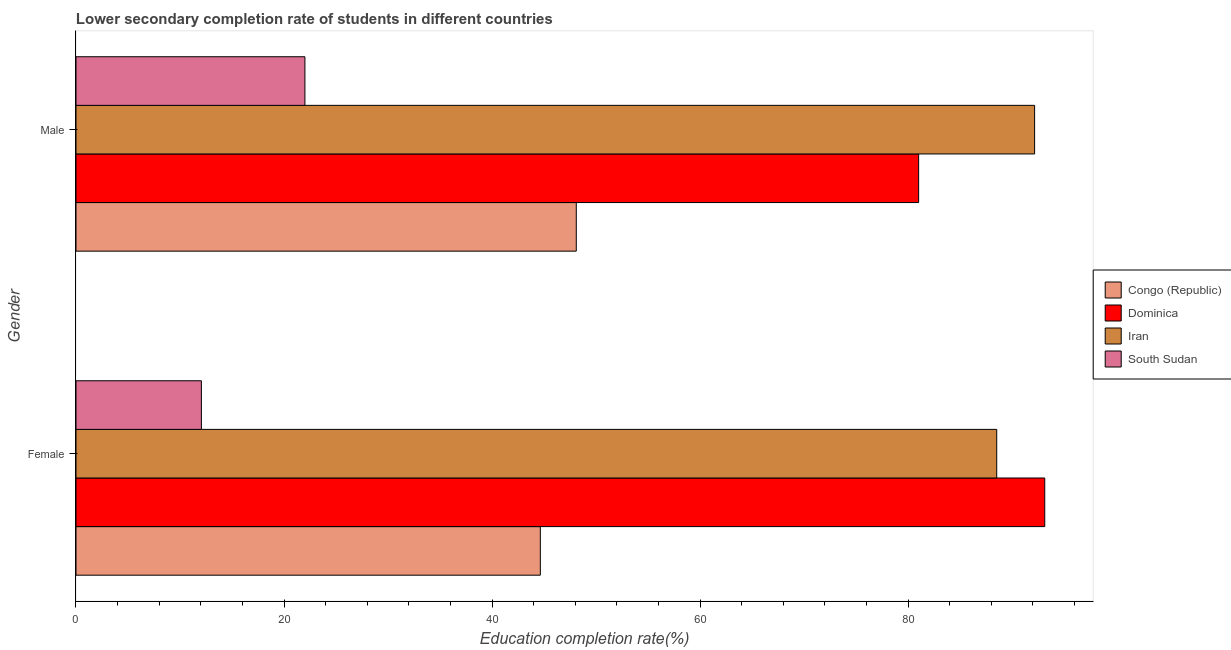How many groups of bars are there?
Make the answer very short. 2. Are the number of bars on each tick of the Y-axis equal?
Your answer should be compact. Yes. What is the label of the 2nd group of bars from the top?
Your response must be concise. Female. What is the education completion rate of male students in Dominica?
Ensure brevity in your answer.  81.01. Across all countries, what is the maximum education completion rate of male students?
Offer a very short reply. 92.16. Across all countries, what is the minimum education completion rate of female students?
Your response must be concise. 12.06. In which country was the education completion rate of male students maximum?
Offer a terse response. Iran. In which country was the education completion rate of female students minimum?
Your answer should be very brief. South Sudan. What is the total education completion rate of female students in the graph?
Offer a very short reply. 238.36. What is the difference between the education completion rate of female students in Iran and that in South Sudan?
Provide a succinct answer. 76.47. What is the difference between the education completion rate of male students in Dominica and the education completion rate of female students in Congo (Republic)?
Keep it short and to the point. 36.37. What is the average education completion rate of male students per country?
Ensure brevity in your answer.  60.82. What is the difference between the education completion rate of female students and education completion rate of male students in Iran?
Provide a short and direct response. -3.64. In how many countries, is the education completion rate of male students greater than 20 %?
Offer a terse response. 4. What is the ratio of the education completion rate of male students in Iran to that in Dominica?
Make the answer very short. 1.14. What does the 4th bar from the top in Male represents?
Make the answer very short. Congo (Republic). What does the 4th bar from the bottom in Male represents?
Give a very brief answer. South Sudan. How many bars are there?
Offer a very short reply. 8. Are the values on the major ticks of X-axis written in scientific E-notation?
Offer a terse response. No. Where does the legend appear in the graph?
Offer a very short reply. Center right. What is the title of the graph?
Provide a succinct answer. Lower secondary completion rate of students in different countries. Does "South Sudan" appear as one of the legend labels in the graph?
Offer a terse response. Yes. What is the label or title of the X-axis?
Make the answer very short. Education completion rate(%). What is the Education completion rate(%) in Congo (Republic) in Female?
Your answer should be compact. 44.64. What is the Education completion rate(%) in Dominica in Female?
Offer a very short reply. 93.14. What is the Education completion rate(%) of Iran in Female?
Ensure brevity in your answer.  88.52. What is the Education completion rate(%) in South Sudan in Female?
Provide a short and direct response. 12.06. What is the Education completion rate(%) of Congo (Republic) in Male?
Provide a short and direct response. 48.1. What is the Education completion rate(%) of Dominica in Male?
Provide a short and direct response. 81.01. What is the Education completion rate(%) of Iran in Male?
Your answer should be compact. 92.16. What is the Education completion rate(%) of South Sudan in Male?
Provide a short and direct response. 22.01. Across all Gender, what is the maximum Education completion rate(%) in Congo (Republic)?
Your response must be concise. 48.1. Across all Gender, what is the maximum Education completion rate(%) of Dominica?
Keep it short and to the point. 93.14. Across all Gender, what is the maximum Education completion rate(%) in Iran?
Provide a short and direct response. 92.16. Across all Gender, what is the maximum Education completion rate(%) in South Sudan?
Offer a very short reply. 22.01. Across all Gender, what is the minimum Education completion rate(%) in Congo (Republic)?
Your answer should be very brief. 44.64. Across all Gender, what is the minimum Education completion rate(%) of Dominica?
Provide a succinct answer. 81.01. Across all Gender, what is the minimum Education completion rate(%) in Iran?
Offer a very short reply. 88.52. Across all Gender, what is the minimum Education completion rate(%) of South Sudan?
Ensure brevity in your answer.  12.06. What is the total Education completion rate(%) of Congo (Republic) in the graph?
Your answer should be very brief. 92.74. What is the total Education completion rate(%) in Dominica in the graph?
Provide a succinct answer. 174.15. What is the total Education completion rate(%) of Iran in the graph?
Offer a very short reply. 180.69. What is the total Education completion rate(%) in South Sudan in the graph?
Offer a very short reply. 34.07. What is the difference between the Education completion rate(%) in Congo (Republic) in Female and that in Male?
Offer a terse response. -3.46. What is the difference between the Education completion rate(%) in Dominica in Female and that in Male?
Provide a succinct answer. 12.13. What is the difference between the Education completion rate(%) of Iran in Female and that in Male?
Give a very brief answer. -3.64. What is the difference between the Education completion rate(%) of South Sudan in Female and that in Male?
Make the answer very short. -9.95. What is the difference between the Education completion rate(%) in Congo (Republic) in Female and the Education completion rate(%) in Dominica in Male?
Provide a succinct answer. -36.37. What is the difference between the Education completion rate(%) of Congo (Republic) in Female and the Education completion rate(%) of Iran in Male?
Keep it short and to the point. -47.52. What is the difference between the Education completion rate(%) of Congo (Republic) in Female and the Education completion rate(%) of South Sudan in Male?
Offer a very short reply. 22.63. What is the difference between the Education completion rate(%) of Dominica in Female and the Education completion rate(%) of Iran in Male?
Provide a succinct answer. 0.98. What is the difference between the Education completion rate(%) of Dominica in Female and the Education completion rate(%) of South Sudan in Male?
Your answer should be compact. 71.13. What is the difference between the Education completion rate(%) in Iran in Female and the Education completion rate(%) in South Sudan in Male?
Your answer should be very brief. 66.51. What is the average Education completion rate(%) in Congo (Republic) per Gender?
Offer a very short reply. 46.37. What is the average Education completion rate(%) of Dominica per Gender?
Offer a terse response. 87.08. What is the average Education completion rate(%) in Iran per Gender?
Your answer should be very brief. 90.34. What is the average Education completion rate(%) of South Sudan per Gender?
Give a very brief answer. 17.03. What is the difference between the Education completion rate(%) of Congo (Republic) and Education completion rate(%) of Dominica in Female?
Make the answer very short. -48.5. What is the difference between the Education completion rate(%) of Congo (Republic) and Education completion rate(%) of Iran in Female?
Offer a terse response. -43.88. What is the difference between the Education completion rate(%) in Congo (Republic) and Education completion rate(%) in South Sudan in Female?
Give a very brief answer. 32.59. What is the difference between the Education completion rate(%) in Dominica and Education completion rate(%) in Iran in Female?
Your answer should be very brief. 4.62. What is the difference between the Education completion rate(%) of Dominica and Education completion rate(%) of South Sudan in Female?
Your response must be concise. 81.08. What is the difference between the Education completion rate(%) of Iran and Education completion rate(%) of South Sudan in Female?
Your response must be concise. 76.47. What is the difference between the Education completion rate(%) in Congo (Republic) and Education completion rate(%) in Dominica in Male?
Keep it short and to the point. -32.91. What is the difference between the Education completion rate(%) in Congo (Republic) and Education completion rate(%) in Iran in Male?
Your response must be concise. -44.06. What is the difference between the Education completion rate(%) of Congo (Republic) and Education completion rate(%) of South Sudan in Male?
Keep it short and to the point. 26.09. What is the difference between the Education completion rate(%) in Dominica and Education completion rate(%) in Iran in Male?
Your response must be concise. -11.15. What is the difference between the Education completion rate(%) in Dominica and Education completion rate(%) in South Sudan in Male?
Make the answer very short. 59. What is the difference between the Education completion rate(%) of Iran and Education completion rate(%) of South Sudan in Male?
Give a very brief answer. 70.15. What is the ratio of the Education completion rate(%) of Congo (Republic) in Female to that in Male?
Your answer should be compact. 0.93. What is the ratio of the Education completion rate(%) in Dominica in Female to that in Male?
Offer a very short reply. 1.15. What is the ratio of the Education completion rate(%) in Iran in Female to that in Male?
Your answer should be compact. 0.96. What is the ratio of the Education completion rate(%) in South Sudan in Female to that in Male?
Give a very brief answer. 0.55. What is the difference between the highest and the second highest Education completion rate(%) in Congo (Republic)?
Provide a short and direct response. 3.46. What is the difference between the highest and the second highest Education completion rate(%) of Dominica?
Make the answer very short. 12.13. What is the difference between the highest and the second highest Education completion rate(%) of Iran?
Offer a very short reply. 3.64. What is the difference between the highest and the second highest Education completion rate(%) of South Sudan?
Provide a short and direct response. 9.95. What is the difference between the highest and the lowest Education completion rate(%) of Congo (Republic)?
Provide a succinct answer. 3.46. What is the difference between the highest and the lowest Education completion rate(%) of Dominica?
Provide a short and direct response. 12.13. What is the difference between the highest and the lowest Education completion rate(%) of Iran?
Your answer should be compact. 3.64. What is the difference between the highest and the lowest Education completion rate(%) of South Sudan?
Give a very brief answer. 9.95. 